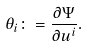<formula> <loc_0><loc_0><loc_500><loc_500>\theta _ { i } \colon = \frac { \partial \Psi } { \partial { u ^ { i } } } .</formula> 